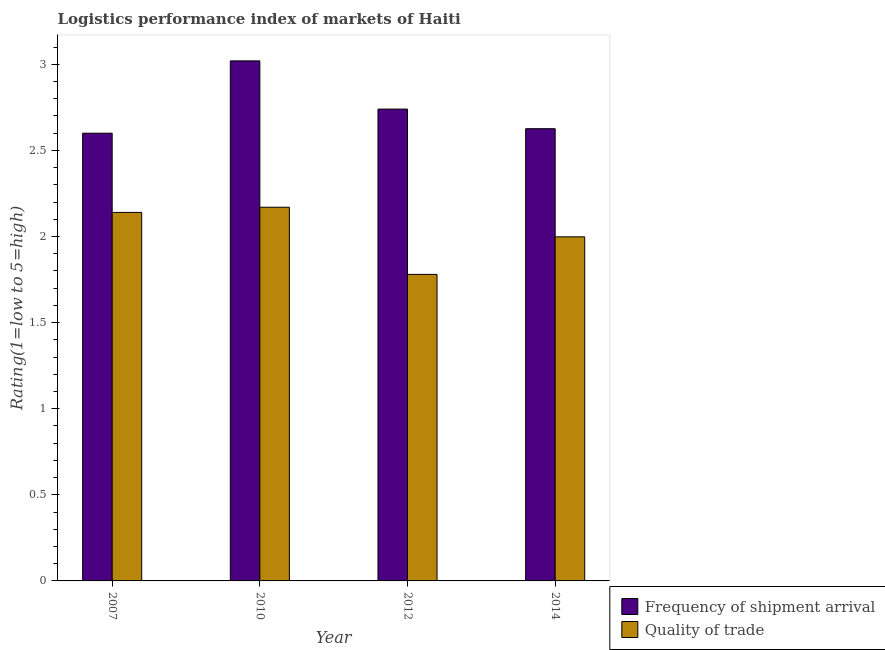Are the number of bars per tick equal to the number of legend labels?
Keep it short and to the point. Yes. How many bars are there on the 1st tick from the left?
Your answer should be very brief. 2. What is the lpi quality of trade in 2007?
Make the answer very short. 2.14. Across all years, what is the maximum lpi of frequency of shipment arrival?
Your answer should be very brief. 3.02. Across all years, what is the minimum lpi quality of trade?
Your answer should be compact. 1.78. In which year was the lpi of frequency of shipment arrival minimum?
Your answer should be very brief. 2007. What is the total lpi quality of trade in the graph?
Your answer should be very brief. 8.09. What is the difference between the lpi of frequency of shipment arrival in 2010 and that in 2014?
Keep it short and to the point. 0.39. What is the difference between the lpi of frequency of shipment arrival in 2010 and the lpi quality of trade in 2007?
Your response must be concise. 0.42. What is the average lpi of frequency of shipment arrival per year?
Offer a terse response. 2.75. What is the ratio of the lpi of frequency of shipment arrival in 2007 to that in 2012?
Provide a succinct answer. 0.95. What is the difference between the highest and the second highest lpi quality of trade?
Your answer should be very brief. 0.03. What is the difference between the highest and the lowest lpi of frequency of shipment arrival?
Offer a terse response. 0.42. In how many years, is the lpi quality of trade greater than the average lpi quality of trade taken over all years?
Give a very brief answer. 2. Is the sum of the lpi of frequency of shipment arrival in 2007 and 2010 greater than the maximum lpi quality of trade across all years?
Ensure brevity in your answer.  Yes. What does the 2nd bar from the left in 2012 represents?
Provide a succinct answer. Quality of trade. What does the 1st bar from the right in 2007 represents?
Offer a very short reply. Quality of trade. Are all the bars in the graph horizontal?
Provide a short and direct response. No. How many years are there in the graph?
Your answer should be very brief. 4. Are the values on the major ticks of Y-axis written in scientific E-notation?
Your response must be concise. No. Does the graph contain any zero values?
Your response must be concise. No. Does the graph contain grids?
Your response must be concise. No. Where does the legend appear in the graph?
Make the answer very short. Bottom right. How many legend labels are there?
Make the answer very short. 2. What is the title of the graph?
Keep it short and to the point. Logistics performance index of markets of Haiti. What is the label or title of the X-axis?
Offer a terse response. Year. What is the label or title of the Y-axis?
Offer a terse response. Rating(1=low to 5=high). What is the Rating(1=low to 5=high) of Frequency of shipment arrival in 2007?
Your response must be concise. 2.6. What is the Rating(1=low to 5=high) of Quality of trade in 2007?
Your answer should be very brief. 2.14. What is the Rating(1=low to 5=high) in Frequency of shipment arrival in 2010?
Keep it short and to the point. 3.02. What is the Rating(1=low to 5=high) of Quality of trade in 2010?
Give a very brief answer. 2.17. What is the Rating(1=low to 5=high) of Frequency of shipment arrival in 2012?
Provide a succinct answer. 2.74. What is the Rating(1=low to 5=high) in Quality of trade in 2012?
Offer a terse response. 1.78. What is the Rating(1=low to 5=high) of Frequency of shipment arrival in 2014?
Provide a short and direct response. 2.63. What is the Rating(1=low to 5=high) of Quality of trade in 2014?
Provide a succinct answer. 2. Across all years, what is the maximum Rating(1=low to 5=high) in Frequency of shipment arrival?
Offer a very short reply. 3.02. Across all years, what is the maximum Rating(1=low to 5=high) of Quality of trade?
Give a very brief answer. 2.17. Across all years, what is the minimum Rating(1=low to 5=high) of Frequency of shipment arrival?
Your answer should be compact. 2.6. Across all years, what is the minimum Rating(1=low to 5=high) in Quality of trade?
Provide a short and direct response. 1.78. What is the total Rating(1=low to 5=high) in Frequency of shipment arrival in the graph?
Keep it short and to the point. 10.99. What is the total Rating(1=low to 5=high) of Quality of trade in the graph?
Make the answer very short. 8.09. What is the difference between the Rating(1=low to 5=high) of Frequency of shipment arrival in 2007 and that in 2010?
Your answer should be very brief. -0.42. What is the difference between the Rating(1=low to 5=high) of Quality of trade in 2007 and that in 2010?
Your response must be concise. -0.03. What is the difference between the Rating(1=low to 5=high) in Frequency of shipment arrival in 2007 and that in 2012?
Keep it short and to the point. -0.14. What is the difference between the Rating(1=low to 5=high) of Quality of trade in 2007 and that in 2012?
Your answer should be compact. 0.36. What is the difference between the Rating(1=low to 5=high) of Frequency of shipment arrival in 2007 and that in 2014?
Keep it short and to the point. -0.03. What is the difference between the Rating(1=low to 5=high) in Quality of trade in 2007 and that in 2014?
Ensure brevity in your answer.  0.14. What is the difference between the Rating(1=low to 5=high) of Frequency of shipment arrival in 2010 and that in 2012?
Make the answer very short. 0.28. What is the difference between the Rating(1=low to 5=high) in Quality of trade in 2010 and that in 2012?
Keep it short and to the point. 0.39. What is the difference between the Rating(1=low to 5=high) in Frequency of shipment arrival in 2010 and that in 2014?
Your response must be concise. 0.39. What is the difference between the Rating(1=low to 5=high) in Quality of trade in 2010 and that in 2014?
Offer a terse response. 0.17. What is the difference between the Rating(1=low to 5=high) in Frequency of shipment arrival in 2012 and that in 2014?
Offer a very short reply. 0.11. What is the difference between the Rating(1=low to 5=high) in Quality of trade in 2012 and that in 2014?
Provide a succinct answer. -0.22. What is the difference between the Rating(1=low to 5=high) of Frequency of shipment arrival in 2007 and the Rating(1=low to 5=high) of Quality of trade in 2010?
Give a very brief answer. 0.43. What is the difference between the Rating(1=low to 5=high) of Frequency of shipment arrival in 2007 and the Rating(1=low to 5=high) of Quality of trade in 2012?
Offer a very short reply. 0.82. What is the difference between the Rating(1=low to 5=high) in Frequency of shipment arrival in 2007 and the Rating(1=low to 5=high) in Quality of trade in 2014?
Your response must be concise. 0.6. What is the difference between the Rating(1=low to 5=high) in Frequency of shipment arrival in 2010 and the Rating(1=low to 5=high) in Quality of trade in 2012?
Make the answer very short. 1.24. What is the difference between the Rating(1=low to 5=high) in Frequency of shipment arrival in 2010 and the Rating(1=low to 5=high) in Quality of trade in 2014?
Provide a succinct answer. 1.02. What is the difference between the Rating(1=low to 5=high) in Frequency of shipment arrival in 2012 and the Rating(1=low to 5=high) in Quality of trade in 2014?
Provide a succinct answer. 0.74. What is the average Rating(1=low to 5=high) in Frequency of shipment arrival per year?
Your answer should be very brief. 2.75. What is the average Rating(1=low to 5=high) of Quality of trade per year?
Provide a short and direct response. 2.02. In the year 2007, what is the difference between the Rating(1=low to 5=high) of Frequency of shipment arrival and Rating(1=low to 5=high) of Quality of trade?
Provide a short and direct response. 0.46. In the year 2014, what is the difference between the Rating(1=low to 5=high) of Frequency of shipment arrival and Rating(1=low to 5=high) of Quality of trade?
Ensure brevity in your answer.  0.63. What is the ratio of the Rating(1=low to 5=high) in Frequency of shipment arrival in 2007 to that in 2010?
Give a very brief answer. 0.86. What is the ratio of the Rating(1=low to 5=high) of Quality of trade in 2007 to that in 2010?
Your response must be concise. 0.99. What is the ratio of the Rating(1=low to 5=high) in Frequency of shipment arrival in 2007 to that in 2012?
Ensure brevity in your answer.  0.95. What is the ratio of the Rating(1=low to 5=high) of Quality of trade in 2007 to that in 2012?
Keep it short and to the point. 1.2. What is the ratio of the Rating(1=low to 5=high) of Frequency of shipment arrival in 2007 to that in 2014?
Offer a terse response. 0.99. What is the ratio of the Rating(1=low to 5=high) of Quality of trade in 2007 to that in 2014?
Offer a terse response. 1.07. What is the ratio of the Rating(1=low to 5=high) in Frequency of shipment arrival in 2010 to that in 2012?
Your answer should be compact. 1.1. What is the ratio of the Rating(1=low to 5=high) of Quality of trade in 2010 to that in 2012?
Make the answer very short. 1.22. What is the ratio of the Rating(1=low to 5=high) of Frequency of shipment arrival in 2010 to that in 2014?
Provide a short and direct response. 1.15. What is the ratio of the Rating(1=low to 5=high) in Quality of trade in 2010 to that in 2014?
Give a very brief answer. 1.09. What is the ratio of the Rating(1=low to 5=high) of Frequency of shipment arrival in 2012 to that in 2014?
Make the answer very short. 1.04. What is the ratio of the Rating(1=low to 5=high) in Quality of trade in 2012 to that in 2014?
Make the answer very short. 0.89. What is the difference between the highest and the second highest Rating(1=low to 5=high) in Frequency of shipment arrival?
Keep it short and to the point. 0.28. What is the difference between the highest and the lowest Rating(1=low to 5=high) of Frequency of shipment arrival?
Your answer should be compact. 0.42. What is the difference between the highest and the lowest Rating(1=low to 5=high) of Quality of trade?
Give a very brief answer. 0.39. 